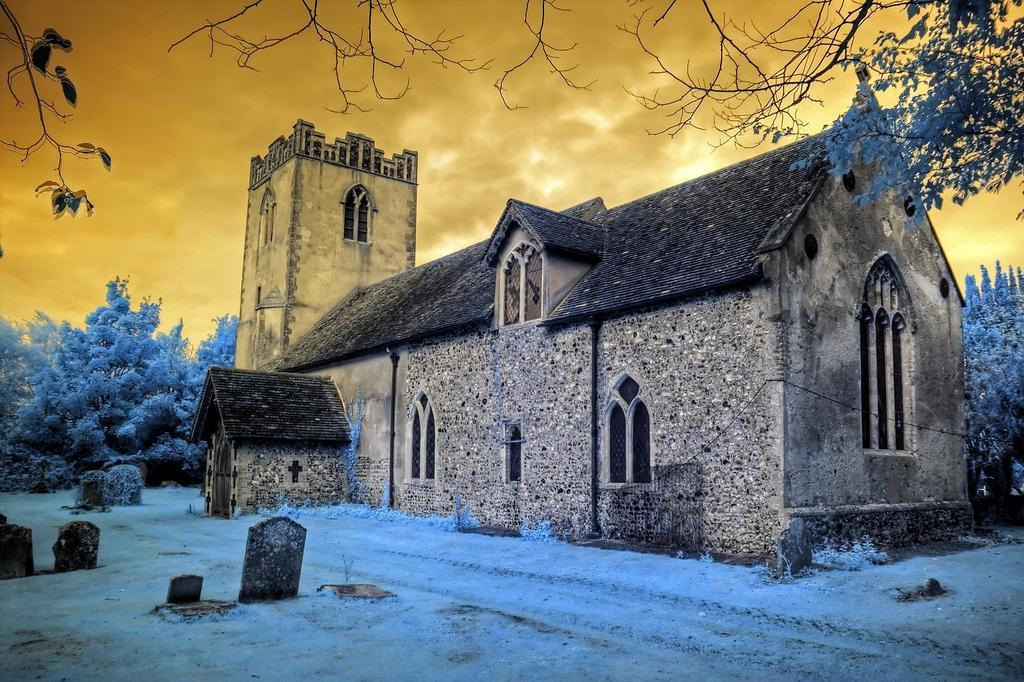What type of structure can be seen in the image? There is a house and a building in the image. What materials are present in the image? There are stones visible in the image. What is the ground like in the image? The ground is visible in the image. What type of vegetation is present in the image? There are trees and branches in the image. What is visible in the background of the image? The sky is visible in the background of the image, and there are clouds in the sky. What type of pleasure can be seen being enjoyed by the passengers in the image? There are no passengers or any indication of pleasure in the image; it features a house, a building, stones, the ground, trees, branches, and a sky with clouds. 